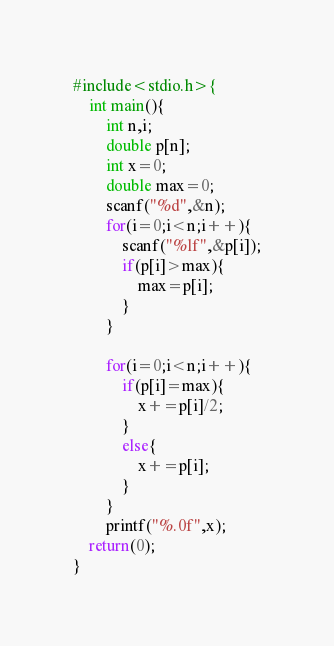<code> <loc_0><loc_0><loc_500><loc_500><_C_>#include<stdio.h>{
	int main(){
		int n,i;
		double p[n];
		int x=0;
		double max=0;
		scanf("%d",&n);
		for(i=0;i<n;i++){
			scanf("%lf",&p[i]);
			if(p[i]>max){
				max=p[i];
			}
		}
		
		for(i=0;i<n;i++){
			if(p[i]=max){
				x+=p[i]/2;
			}
			else{
				x+=p[i];
			}
		}
		printf("%.0f",x);
	return(0);
}</code> 